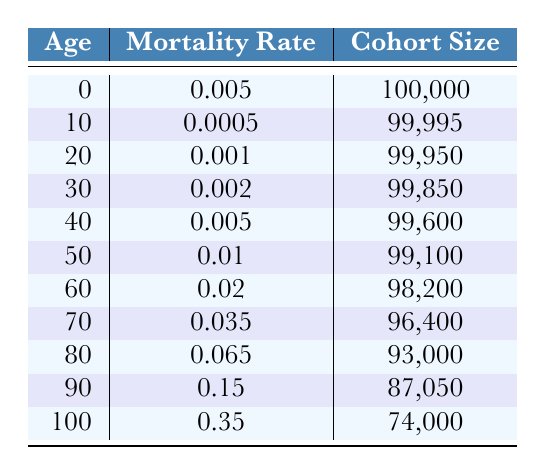What is the mortality rate for individuals aged 40? Referring to the table, under the age group of 40, the listed mortality rate is 0.005.
Answer: 0.005 What is the cohort size for individuals aged 60? According to the table, the cohort size for individuals in the 60 age group is 98,200.
Answer: 98,200 Is the mortality rate for those aged 80 higher than for those aged 70? The mortality rate for age 80 is 0.065, while for age 70 it is 0.035. Since 0.065 is greater than 0.035, the statement is true.
Answer: Yes Calculate the total cohort size for individuals aged 50 and older. The cohort sizes for individuals aged 50, 60, 70, 80, 90, and 100 are 99,100 + 98,200 + 96,400 + 93,000 + 87,050 + 74,000, which sums to 547,750.
Answer: 547,750 What is the average mortality rate for individuals aged 30 and older? The mortality rates for those aged 30 and older are 0.002, 0.005, 0.01, 0.02, 0.035, 0.065, 0.15, and 0.35. Adding these rates gives 0.002 + 0.005 + 0.01 + 0.02 + 0.035 + 0.065 + 0.15 + 0.35 = 0.637. There are 8 data points, thus the average is 0.637/8 = 0.079625.
Answer: 0.079625 Is it true that the mortality rate increases with age? By reviewing the mortality rates in the table, they are 0.005 at age 0, 0.0005 at age 10, increasing consistently as age progresses, reaching 0.35 at age 100. Therefore, yes, it is true.
Answer: Yes What is the difference in mortality rate between individuals aged 90 and those aged 70? The mortality rate for age 90 is 0.15 and for age 70 is 0.035. The difference is 0.15 - 0.035 = 0.115.
Answer: 0.115 How many individuals are there in the 0-10 age group combined? The cohort size for the age 0 group is 100,000 and for age 10 is 99,995. Adding these gives 100,000 + 99,995 = 199,995 individuals.
Answer: 199,995 What is the mortality rate for individuals aged 100? For individuals aged 100, the mortality rate is provided in the table as 0.35.
Answer: 0.35 